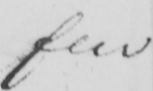Please transcribe the handwritten text in this image. few 